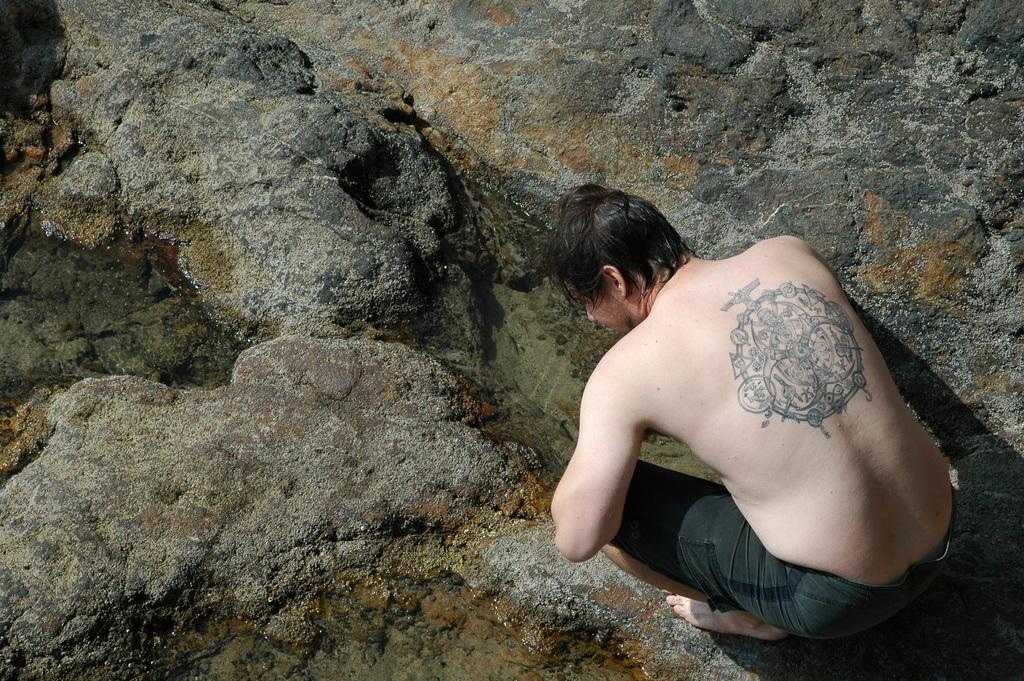Who is present in the image? There is a man in the image. What position is the man in? The man is in a squat position. What can be seen in the background of the image? There is water visible in the image. What type of natural feature is present in the image? There are rocks in the image. What type of hope can be seen in the man's hand in the image? There is no hope present in the image; it is a man in a squat position near water and rocks. 